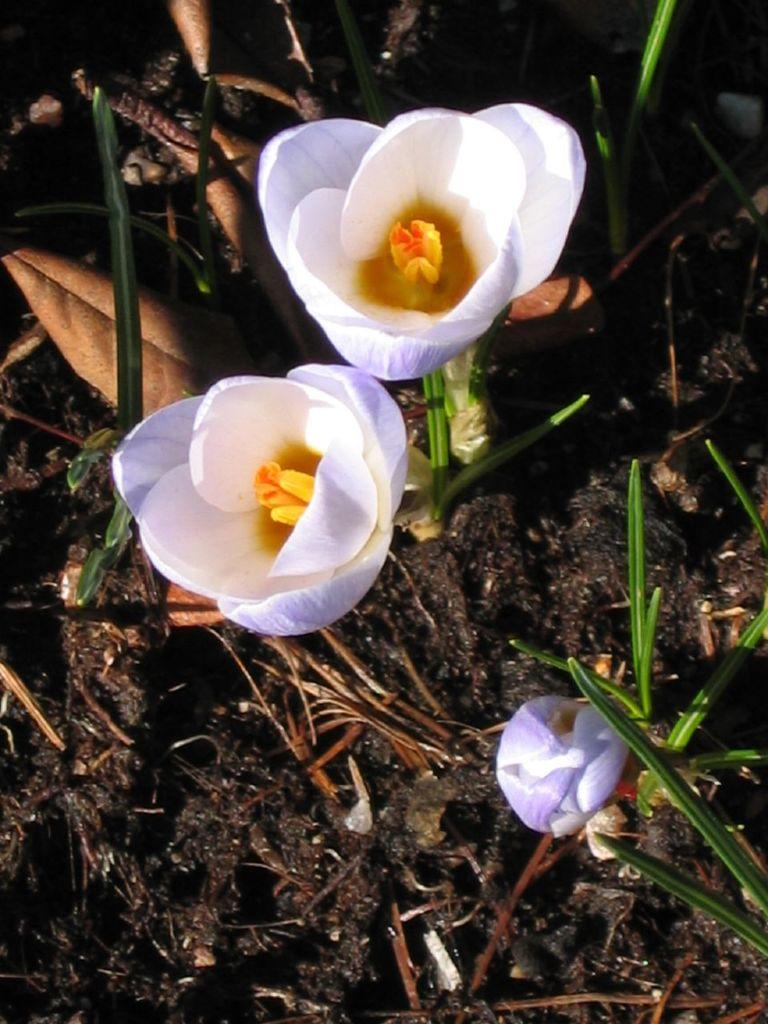What type of plants can be seen in the image? There are flowers in the image. What else can be seen on the ground in the image? There is grass in the image. Where are the flowers and grass located in the image? The flowers and grass are on the ground. What does the stranger believe about the flowers in the image? There is no stranger present in the image, so it is not possible to determine what they might believe about the flowers. 